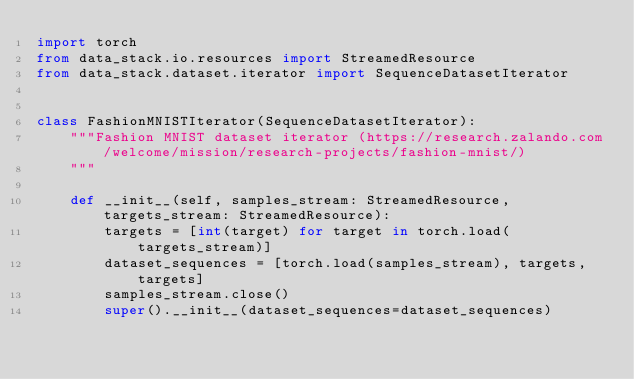Convert code to text. <code><loc_0><loc_0><loc_500><loc_500><_Python_>import torch
from data_stack.io.resources import StreamedResource
from data_stack.dataset.iterator import SequenceDatasetIterator


class FashionMNISTIterator(SequenceDatasetIterator):
    """Fashion MNIST dataset iterator (https://research.zalando.com/welcome/mission/research-projects/fashion-mnist/)
    """

    def __init__(self, samples_stream: StreamedResource, targets_stream: StreamedResource):
        targets = [int(target) for target in torch.load(targets_stream)]
        dataset_sequences = [torch.load(samples_stream), targets, targets]
        samples_stream.close()
        super().__init__(dataset_sequences=dataset_sequences)
</code> 